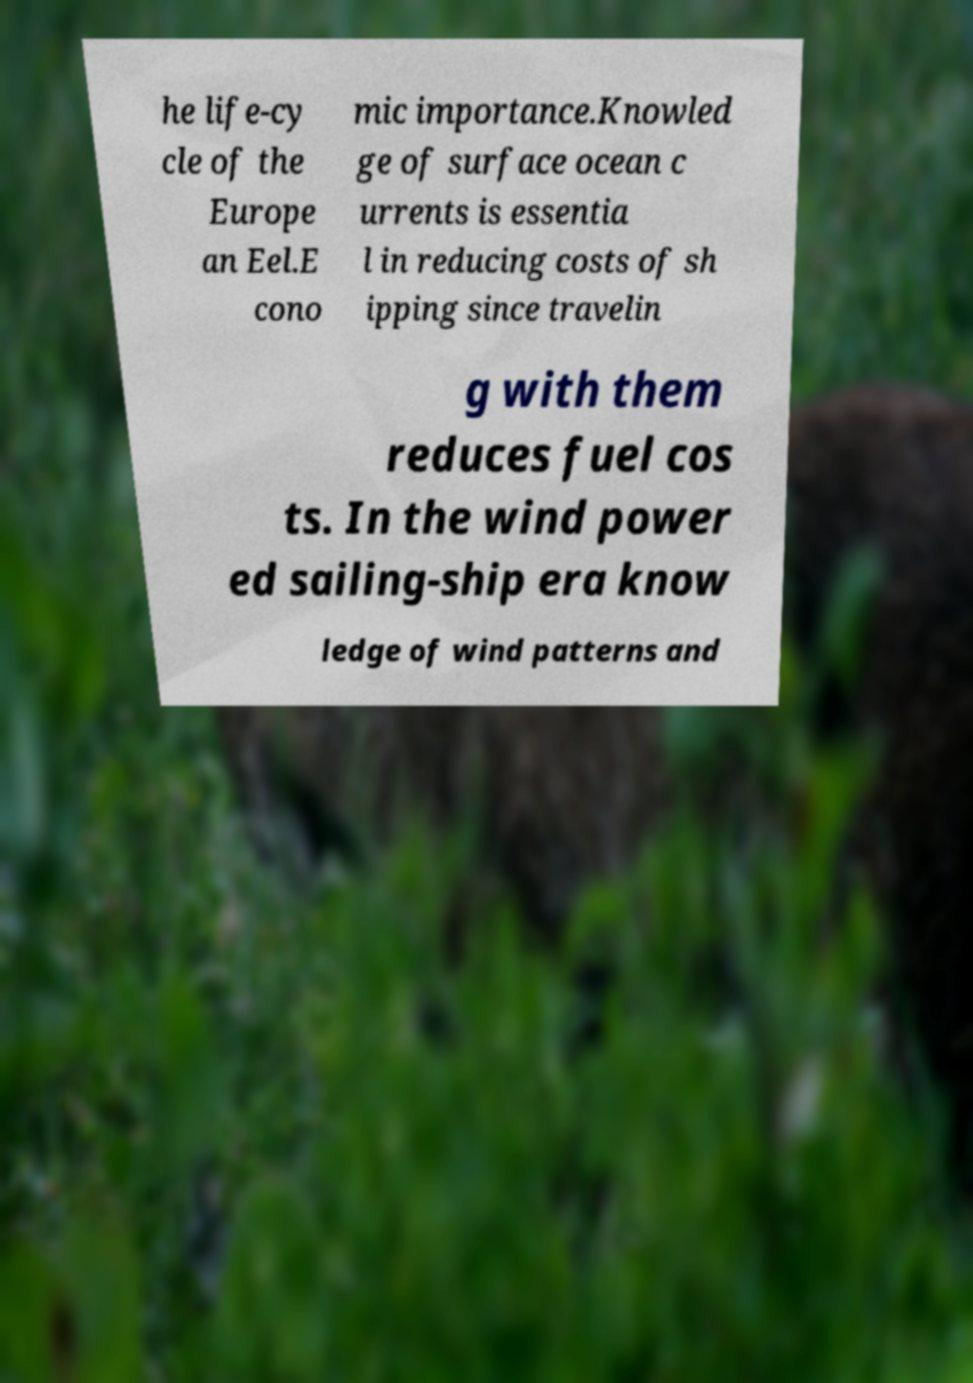Please identify and transcribe the text found in this image. he life-cy cle of the Europe an Eel.E cono mic importance.Knowled ge of surface ocean c urrents is essentia l in reducing costs of sh ipping since travelin g with them reduces fuel cos ts. In the wind power ed sailing-ship era know ledge of wind patterns and 